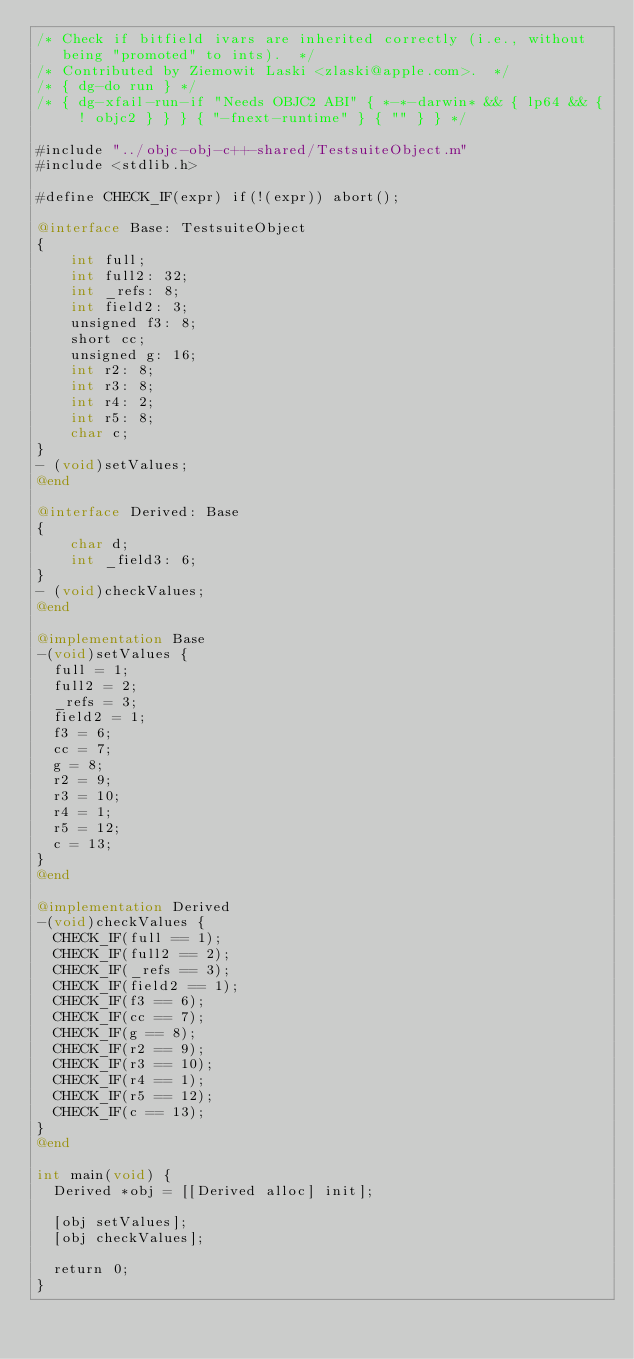Convert code to text. <code><loc_0><loc_0><loc_500><loc_500><_ObjectiveC_>/* Check if bitfield ivars are inherited correctly (i.e., without
   being "promoted" to ints).  */
/* Contributed by Ziemowit Laski <zlaski@apple.com>.  */
/* { dg-do run } */
/* { dg-xfail-run-if "Needs OBJC2 ABI" { *-*-darwin* && { lp64 && { ! objc2 } } } { "-fnext-runtime" } { "" } } */

#include "../objc-obj-c++-shared/TestsuiteObject.m"
#include <stdlib.h>

#define CHECK_IF(expr) if(!(expr)) abort();

@interface Base: TestsuiteObject 
{
    int full;
    int full2: 32;
    int _refs: 8;
    int field2: 3;
    unsigned f3: 8;
    short cc;
    unsigned g: 16;
    int r2: 8;
    int r3: 8;
    int r4: 2;
    int r5: 8;
    char c;
}
- (void)setValues;
@end

@interface Derived: Base
{
    char d;
    int _field3: 6;
}
- (void)checkValues;
@end

@implementation Base
-(void)setValues {
  full = 1;
  full2 = 2;
  _refs = 3;
  field2 = 1;
  f3 = 6;
  cc = 7;
  g = 8;
  r2 = 9;
  r3 = 10;
  r4 = 1;
  r5 = 12;
  c = 13;
}
@end

@implementation Derived
-(void)checkValues {
  CHECK_IF(full == 1);
  CHECK_IF(full2 == 2);
  CHECK_IF(_refs == 3);
  CHECK_IF(field2 == 1);
  CHECK_IF(f3 == 6);
  CHECK_IF(cc == 7);
  CHECK_IF(g == 8);
  CHECK_IF(r2 == 9);
  CHECK_IF(r3 == 10);
  CHECK_IF(r4 == 1);
  CHECK_IF(r5 == 12);
  CHECK_IF(c == 13);
}
@end

int main(void) {
  Derived *obj = [[Derived alloc] init];

  [obj setValues];
  [obj checkValues];

  return 0;
}

</code> 